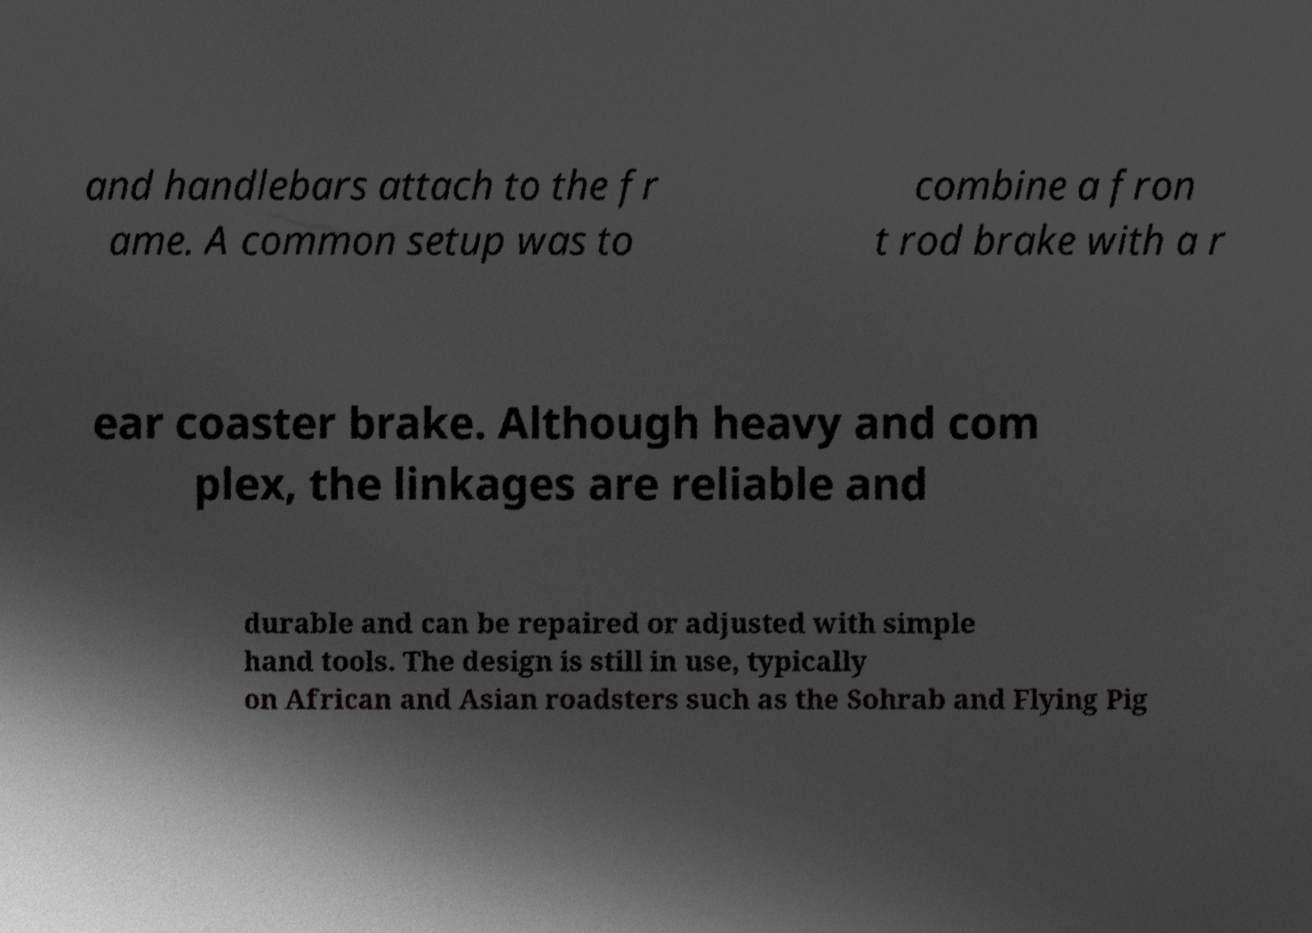Please identify and transcribe the text found in this image. and handlebars attach to the fr ame. A common setup was to combine a fron t rod brake with a r ear coaster brake. Although heavy and com plex, the linkages are reliable and durable and can be repaired or adjusted with simple hand tools. The design is still in use, typically on African and Asian roadsters such as the Sohrab and Flying Pig 